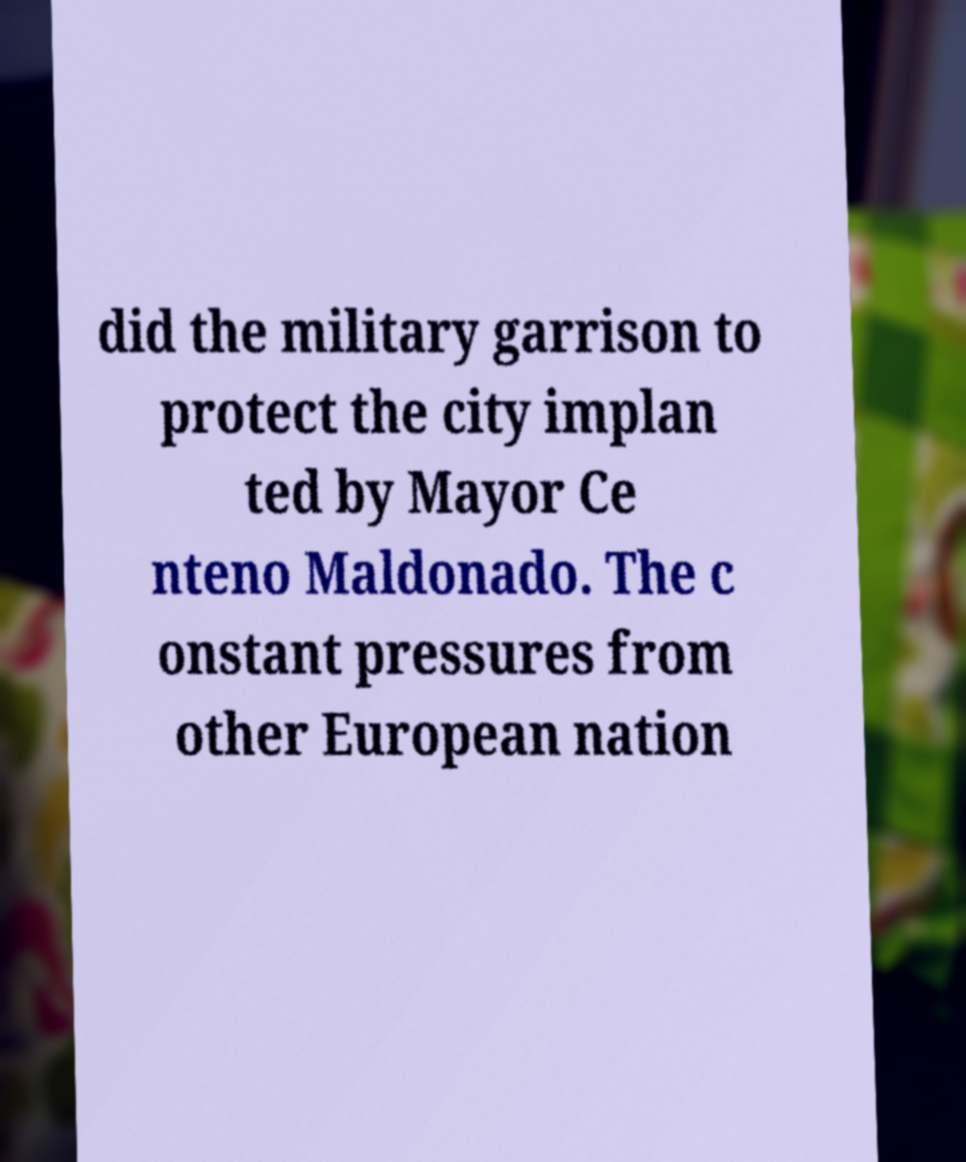Can you accurately transcribe the text from the provided image for me? did the military garrison to protect the city implan ted by Mayor Ce nteno Maldonado. The c onstant pressures from other European nation 